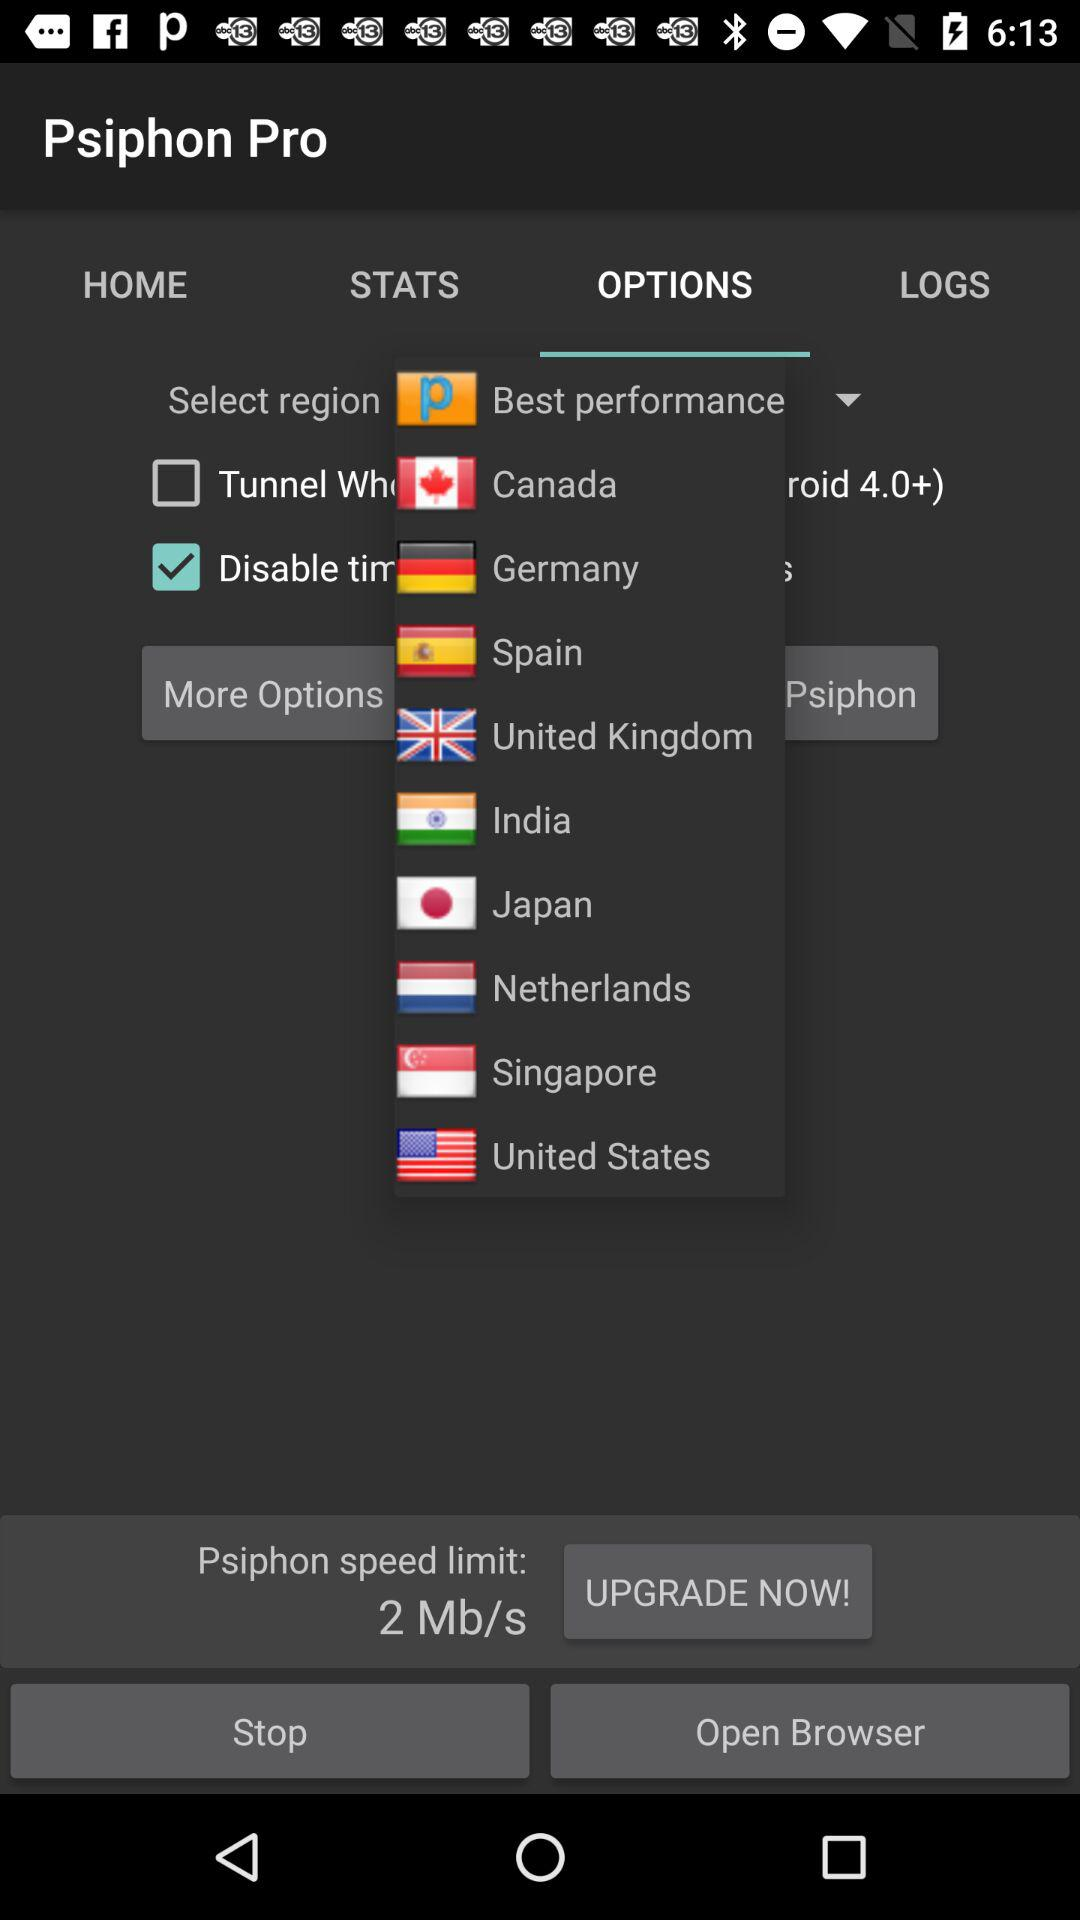What are the names of the countries shown in the "OPTIONS" tab? The names of the countries are Canada, Germany, Spain, the United Kingdom, India, Japan, the Netherlands, Singapore and the United States. 